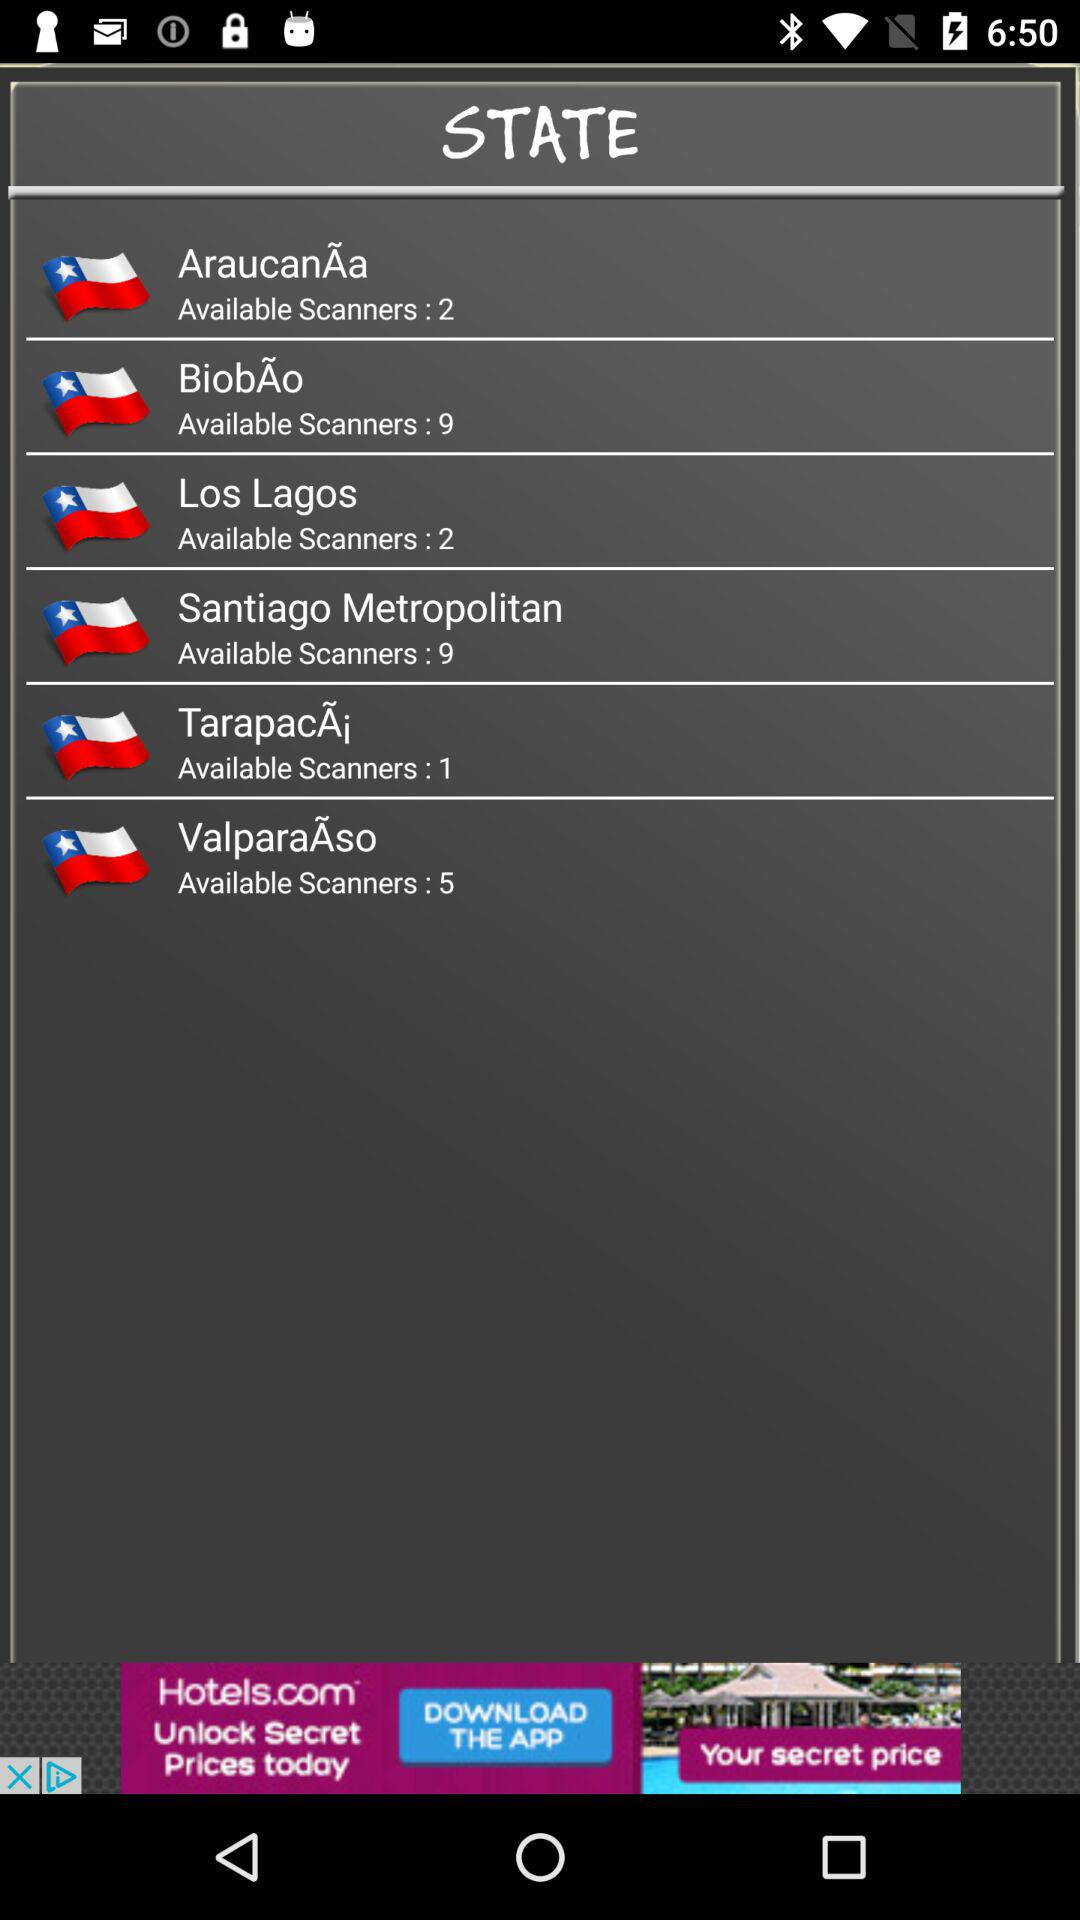How many scanners are there for AraucanÃa? There are 2 scanners for AraucanÃa. 